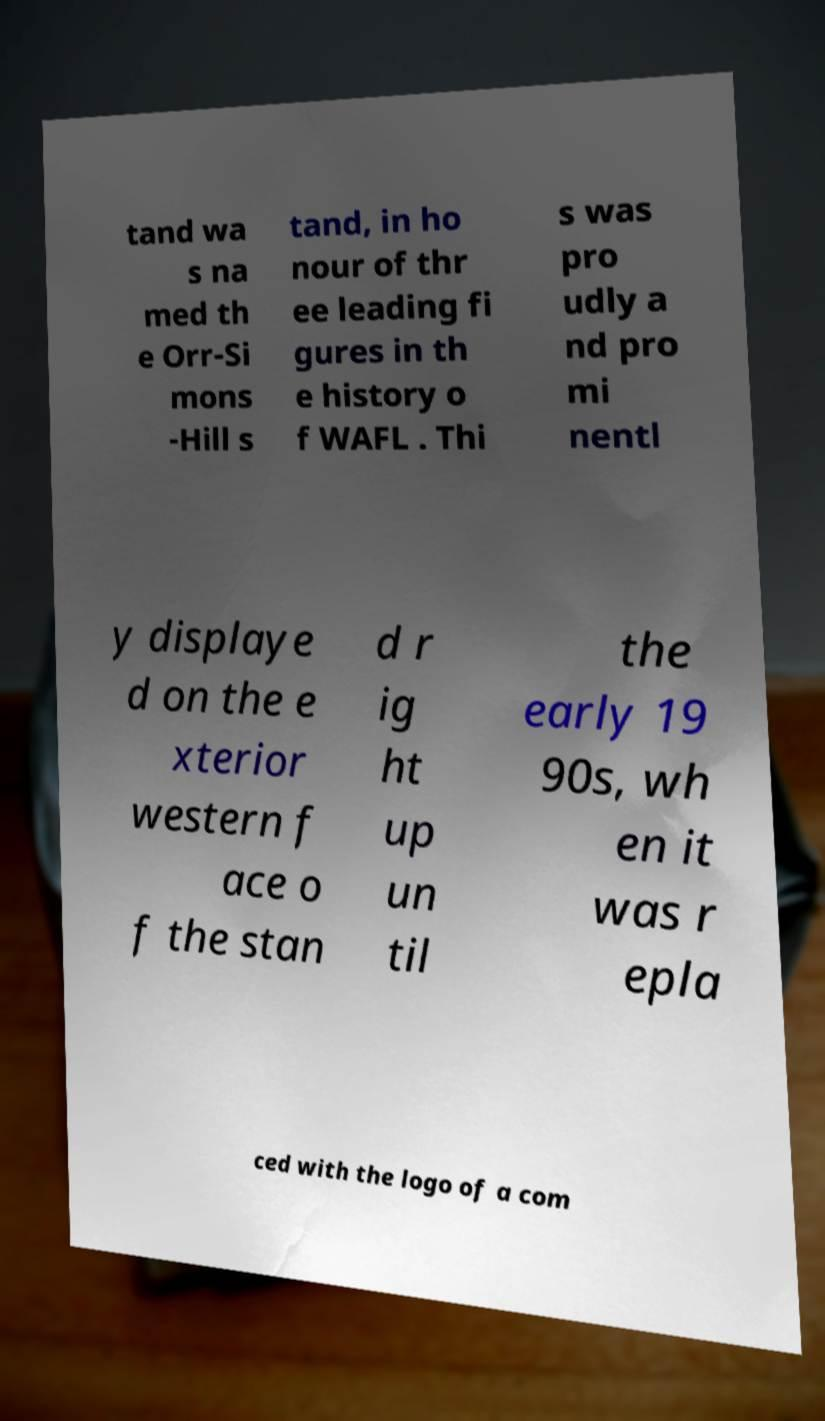What messages or text are displayed in this image? I need them in a readable, typed format. tand wa s na med th e Orr-Si mons -Hill s tand, in ho nour of thr ee leading fi gures in th e history o f WAFL . Thi s was pro udly a nd pro mi nentl y displaye d on the e xterior western f ace o f the stan d r ig ht up un til the early 19 90s, wh en it was r epla ced with the logo of a com 